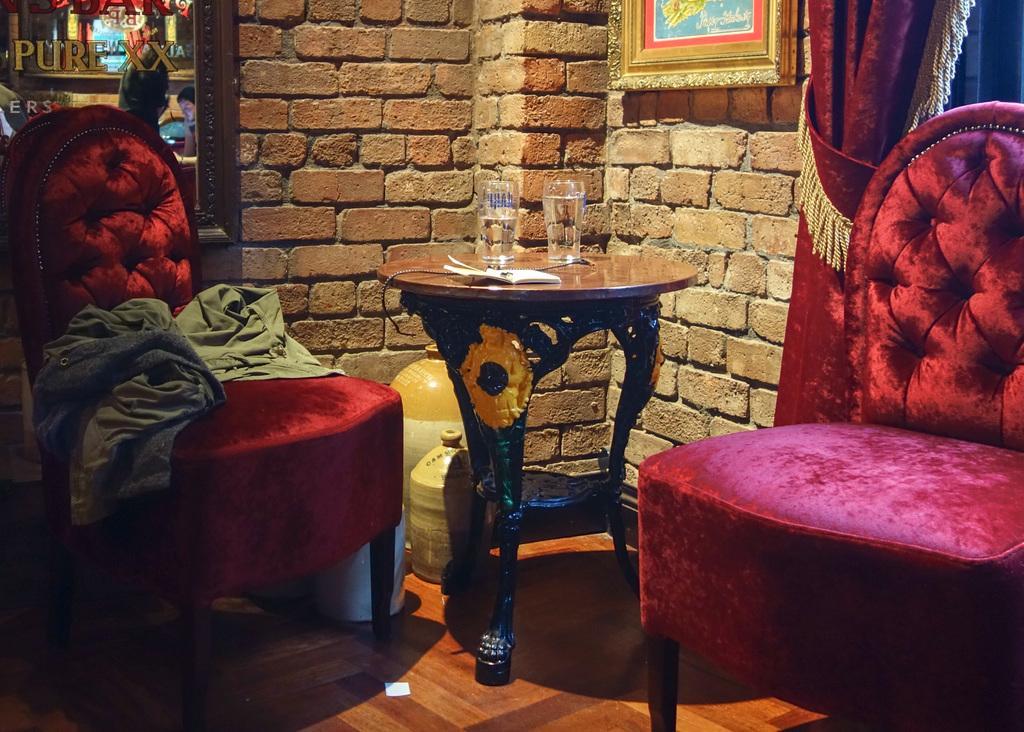In one or two sentences, can you explain what this image depicts? In the middle of the image we can see two chairs and table, on the table we can see a paper and glasses. Behind the table we can see a brick wall. On the wall we can see some frames and curtain. 